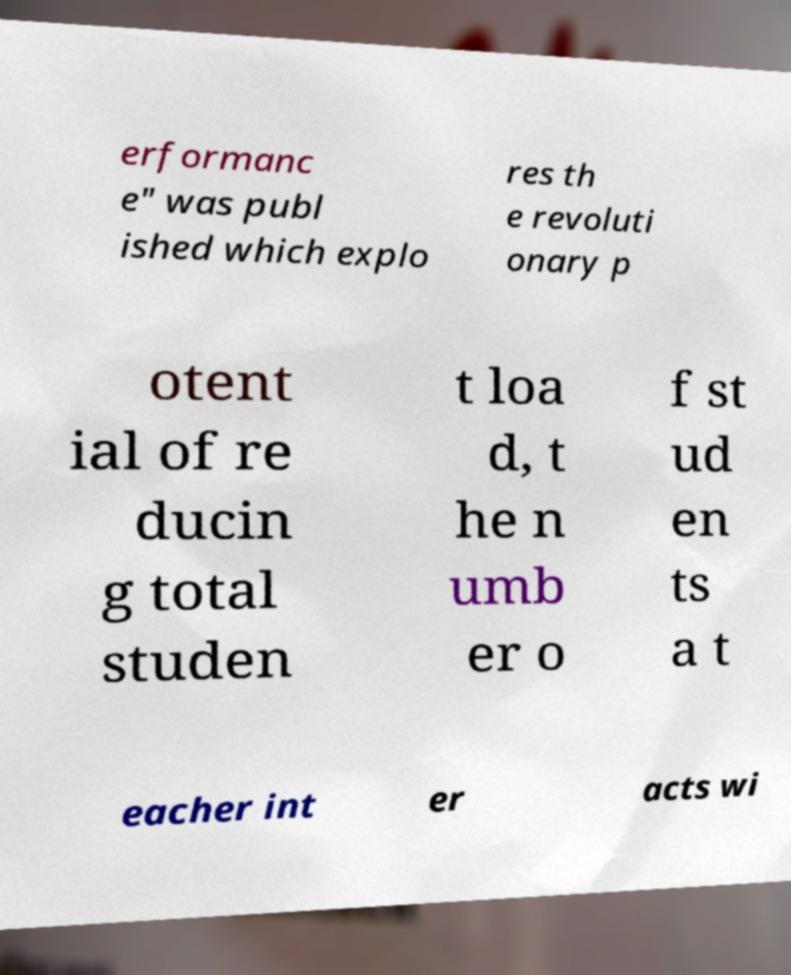Could you extract and type out the text from this image? erformanc e" was publ ished which explo res th e revoluti onary p otent ial of re ducin g total studen t loa d, t he n umb er o f st ud en ts a t eacher int er acts wi 